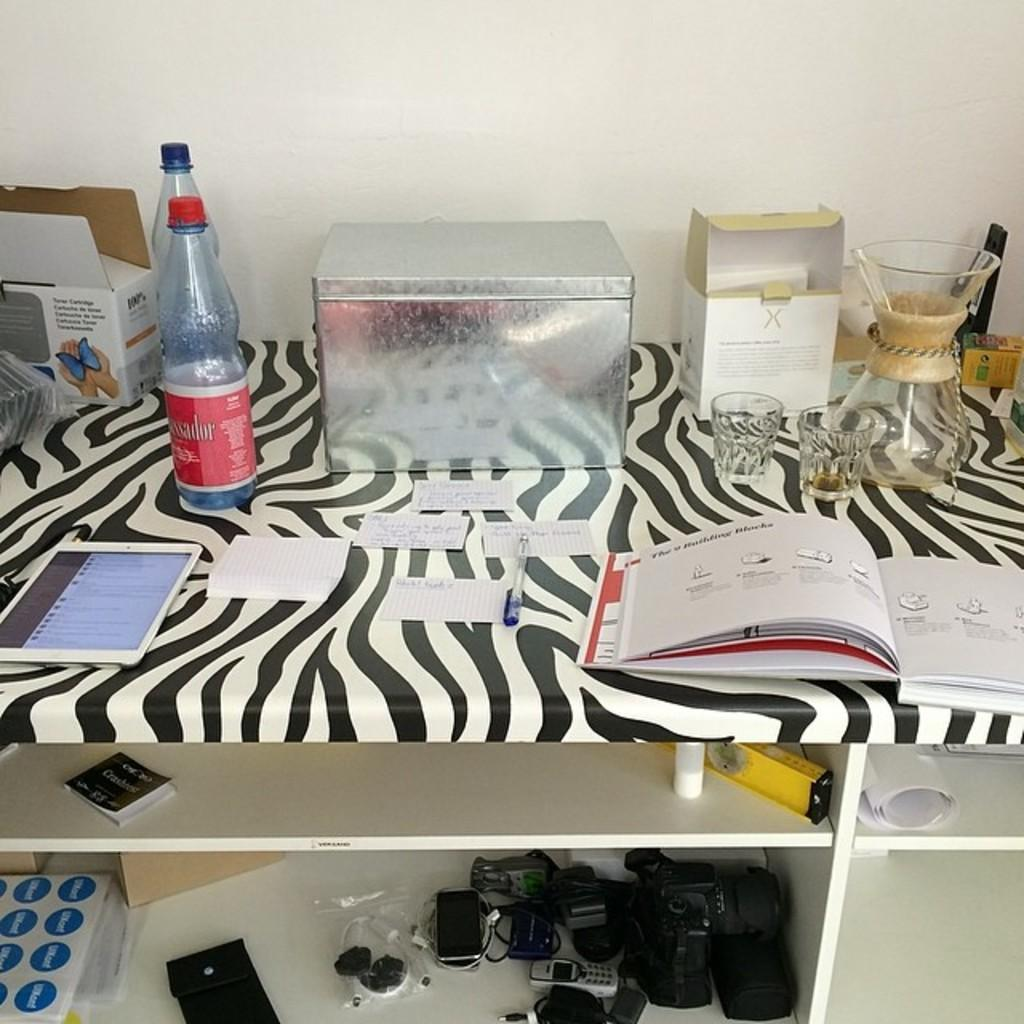What type of furniture is present in the image? There is a shelf in the image. Where is the shelf located in relation to the wall? The shelf is beside a wall. What items can be seen on the shelf? There are bottles, a truck, glasses, books, papers, a tab, a jar, and devices on the shelf. What type of celery is being served at the feast in the image? There is no feast or celery present in the image; it features a shelf with various items on it. What kind of apparatus is used to operate the devices on the shelf? The provided facts do not mention any specific apparatus used to operate the devices on the shelf. 